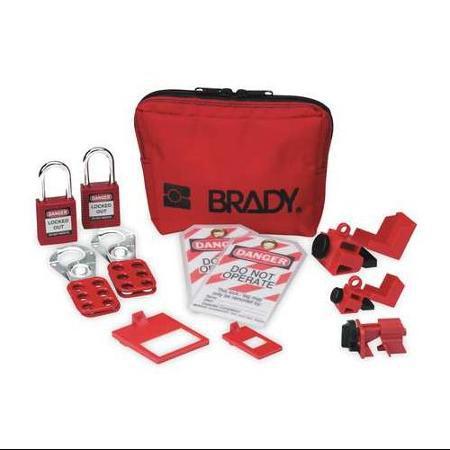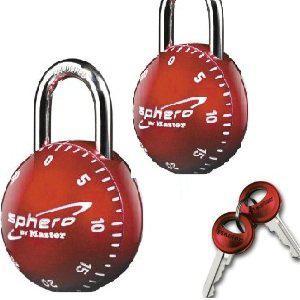The first image is the image on the left, the second image is the image on the right. For the images shown, is this caption "In one image there is a pair of red locks that are in the closed position." true? Answer yes or no. Yes. The first image is the image on the left, the second image is the image on the right. Evaluate the accuracy of this statement regarding the images: "At least two of the locks are combination locks.". Is it true? Answer yes or no. Yes. 